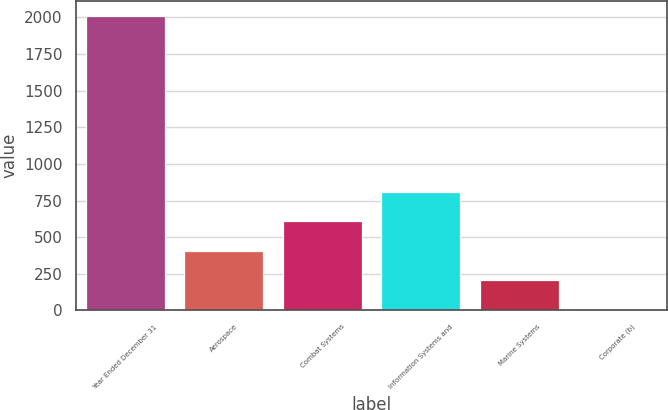<chart> <loc_0><loc_0><loc_500><loc_500><bar_chart><fcel>Year Ended December 31<fcel>Aerospace<fcel>Combat Systems<fcel>Information Systems and<fcel>Marine Systems<fcel>Corporate (b)<nl><fcel>2012<fcel>408<fcel>608.5<fcel>809<fcel>207.5<fcel>7<nl></chart> 